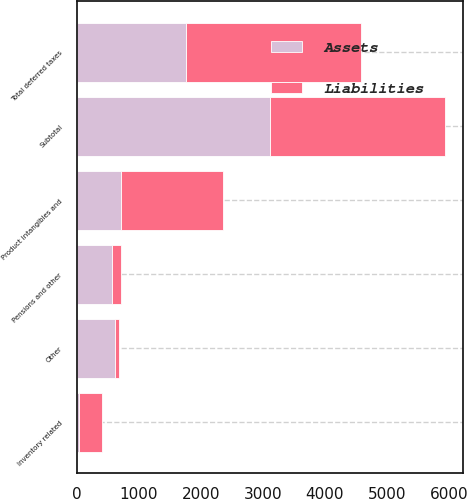Convert chart to OTSL. <chart><loc_0><loc_0><loc_500><loc_500><stacked_bar_chart><ecel><fcel>Product intangibles and<fcel>Inventory related<fcel>Pensions and other<fcel>Other<fcel>Subtotal<fcel>Total deferred taxes<nl><fcel>Assets<fcel>720<fcel>32<fcel>565<fcel>621<fcel>3118<fcel>1770<nl><fcel>Liabilities<fcel>1640<fcel>377<fcel>151<fcel>66<fcel>2816<fcel>2816<nl></chart> 